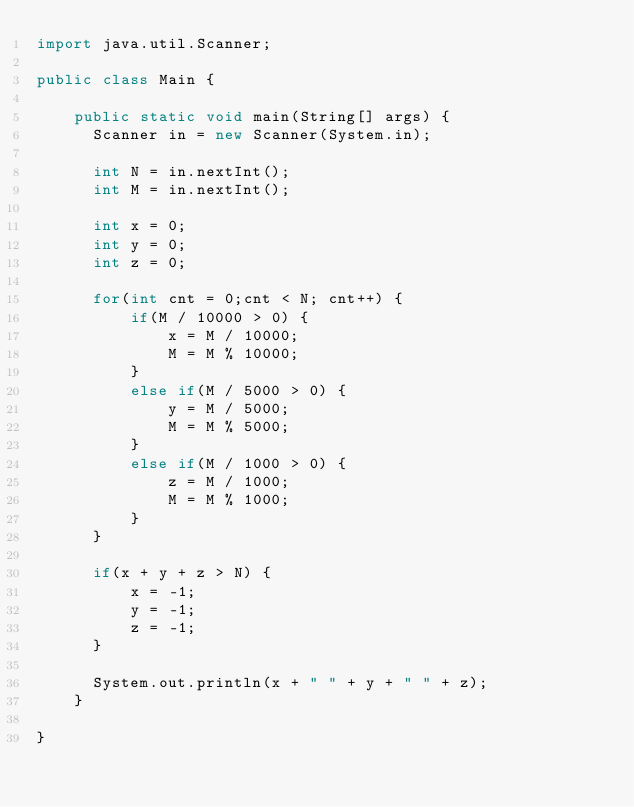<code> <loc_0><loc_0><loc_500><loc_500><_Java_>import java.util.Scanner;

public class Main {

    public static void main(String[] args) {
      Scanner in = new Scanner(System.in);

      int N = in.nextInt();
      int M = in.nextInt();

      int x = 0;
      int y = 0;
      int z = 0;

      for(int cnt = 0;cnt < N; cnt++) {
          if(M / 10000 > 0) {
              x = M / 10000;
              M = M % 10000;
          }
          else if(M / 5000 > 0) {
              y = M / 5000;
              M = M % 5000;
          }
          else if(M / 1000 > 0) {
              z = M / 1000;
              M = M % 1000;
          }
      }

      if(x + y + z > N) {
          x = -1;
          y = -1;
          z = -1;
      }

      System.out.println(x + " " + y + " " + z);
    }

}
</code> 